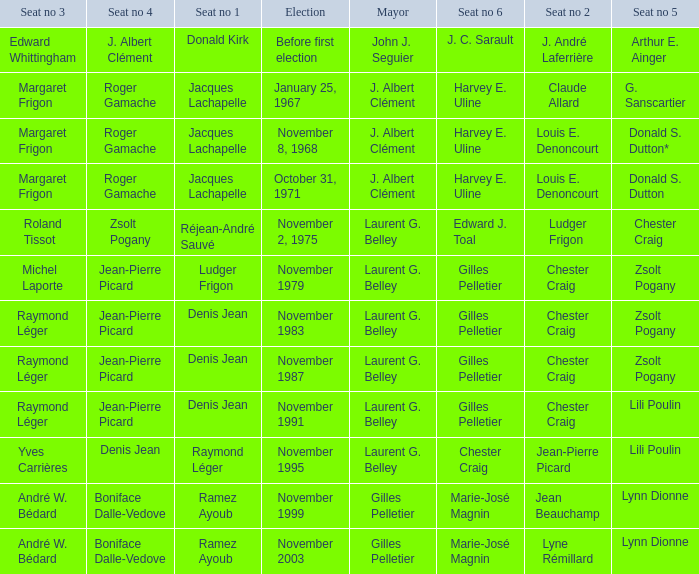Who is seat no 1 when the mayor was john j. seguier Donald Kirk. 